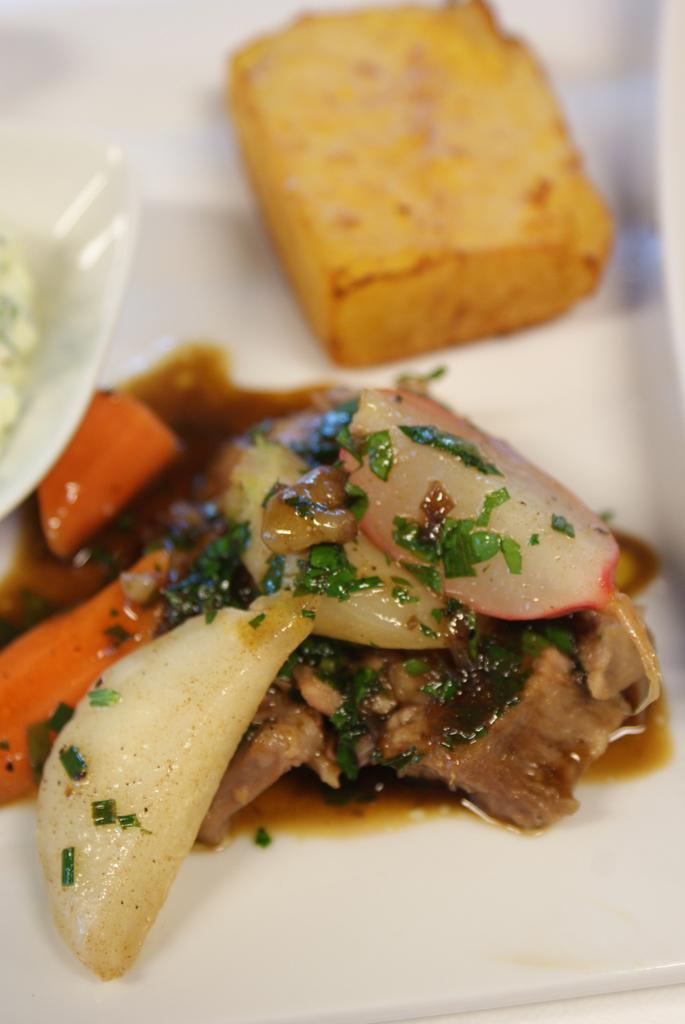What is on the plate that is visible in the image? There is a plate with food in the image. What color is the plate? The plate is white. How would you describe the appearance of the food on the plate? The food is colorful. What else is on the plate besides the food? There is a bowl on the plate. What color is the background of the image? The background of the image is white. Does the plate have a tail in the image? No, the plate does not have a tail in the image. Is the person's brother visible in the image? There is no person or brother present in the image; it only features a plate with food, a bowl, and a white background. 